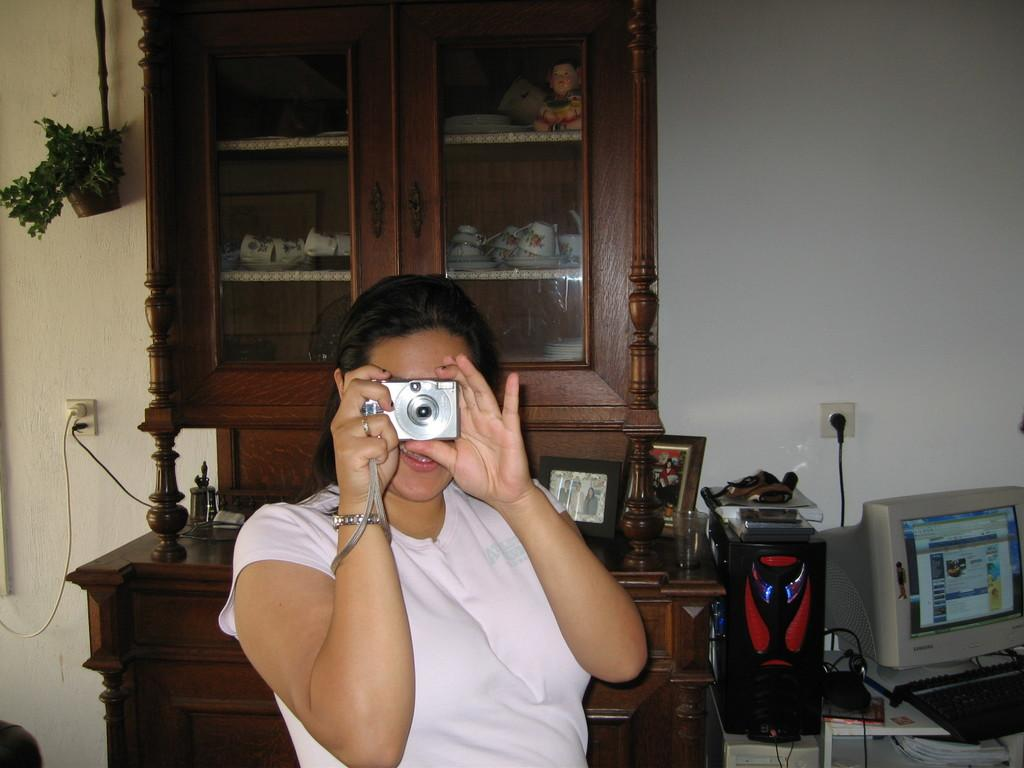What is the woman in the image doing? The woman is sitting in the image and holding a camera in her hands. What might the woman be using the camera for? The woman might be using the camera to take pictures or record a video. What can be seen in the background of the image? There is a computer in the background of the image. What is present on the table in the image? There are objects on a table in the image. What is visible on the side of the image? There is a wall visible in the image. How does the woman cry in the image? There is no indication in the image that the woman is crying, so it cannot be determined from the picture. 